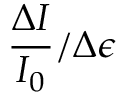<formula> <loc_0><loc_0><loc_500><loc_500>\frac { \Delta I } { I _ { 0 } } / \Delta \epsilon</formula> 